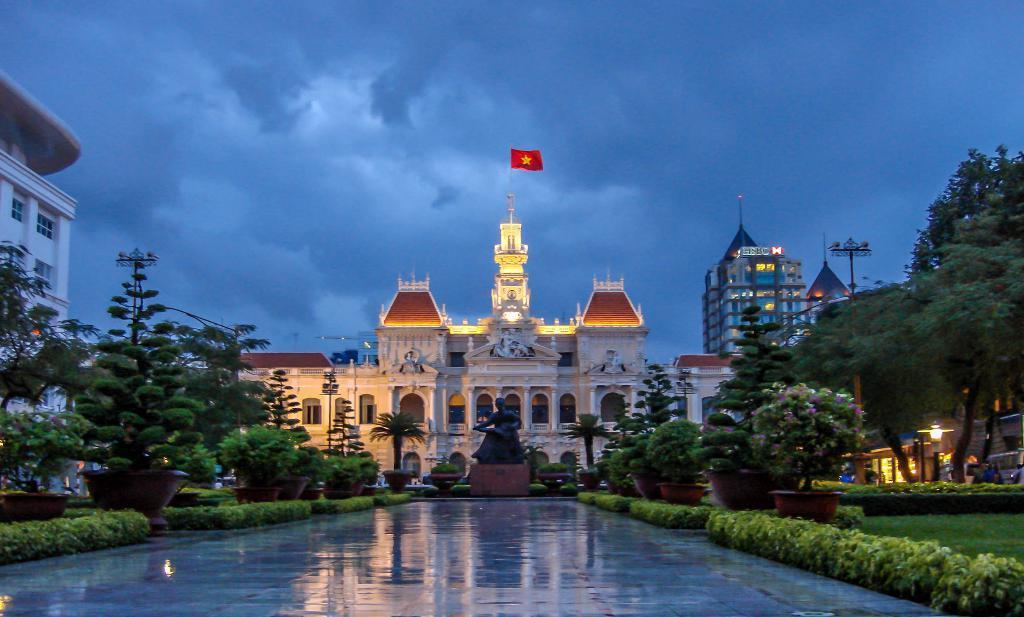Describe this image in one or two sentences. In this image, there are a few buildings. We can see the ground. We can see some grass and plants in pots. There are a few trees. We can see some poles and a statue. We can see a flag and the sky with clouds. We can also see a light pole. 